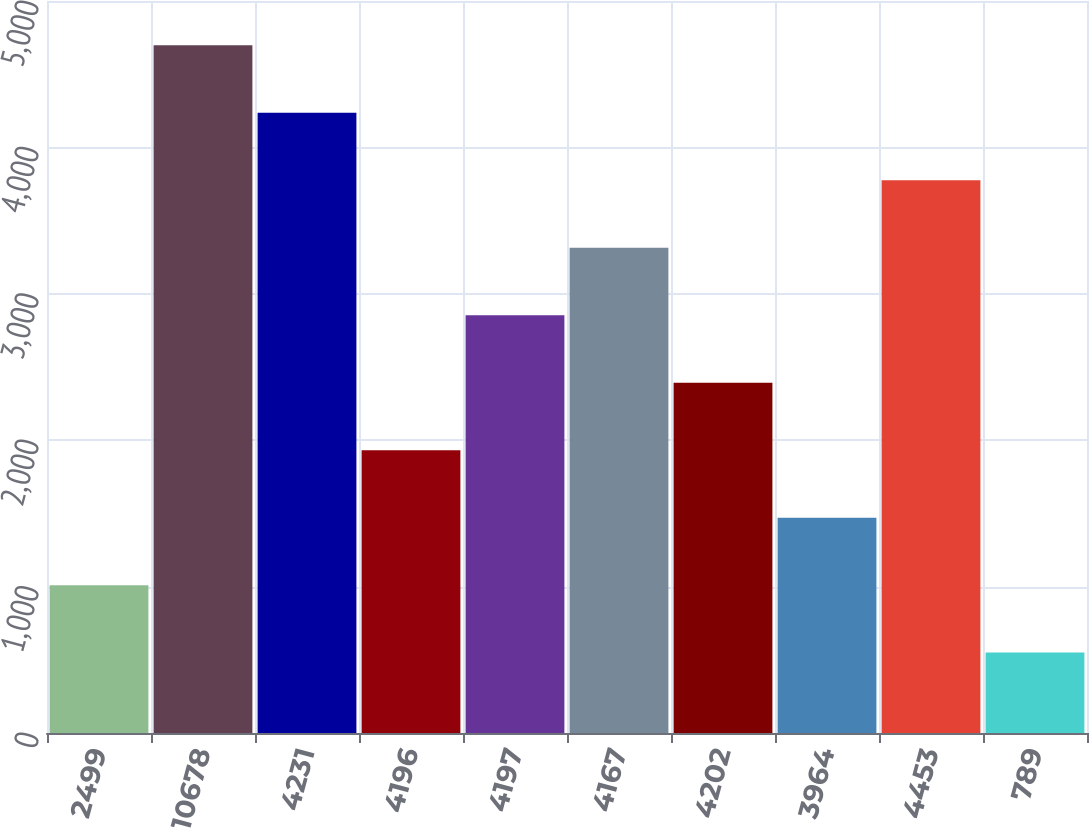<chart> <loc_0><loc_0><loc_500><loc_500><bar_chart><fcel>2499<fcel>10678<fcel>4231<fcel>4196<fcel>4197<fcel>4167<fcel>4202<fcel>3964<fcel>4453<fcel>789<nl><fcel>1009.98<fcel>4697.1<fcel>4236.21<fcel>1931.76<fcel>2853.54<fcel>3314.43<fcel>2392.65<fcel>1470.87<fcel>3775.32<fcel>549.09<nl></chart> 